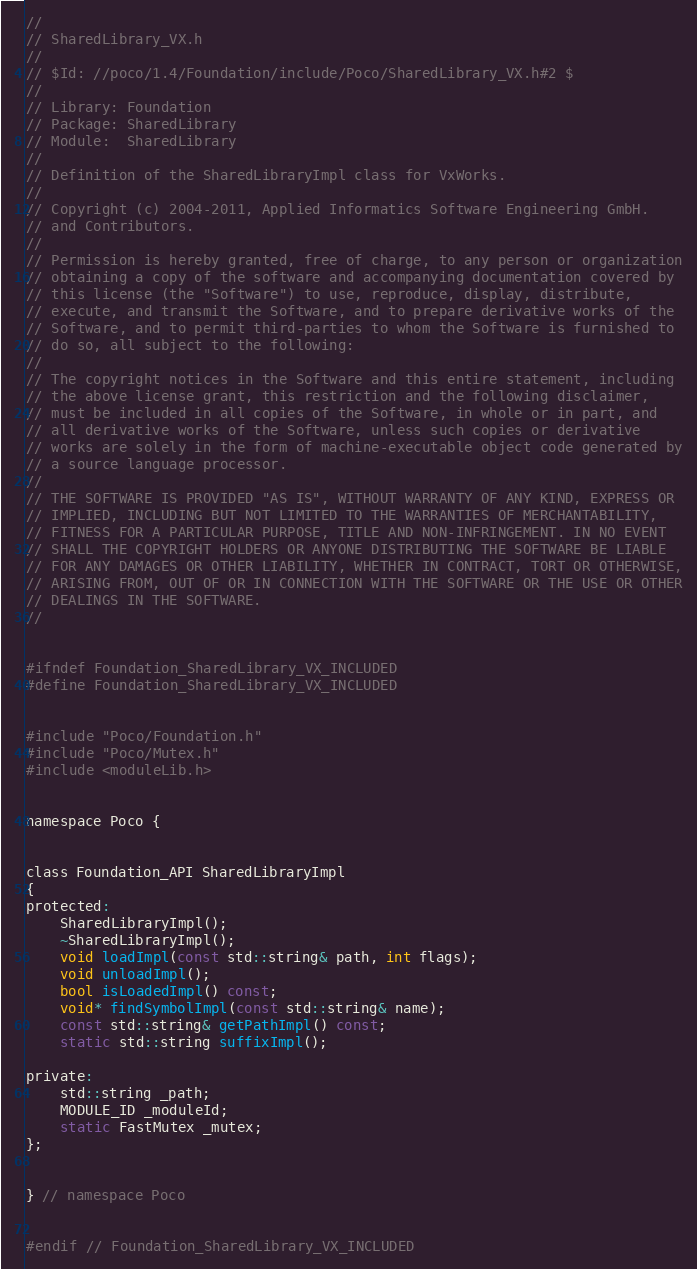Convert code to text. <code><loc_0><loc_0><loc_500><loc_500><_C_>//
// SharedLibrary_VX.h
//
// $Id: //poco/1.4/Foundation/include/Poco/SharedLibrary_VX.h#2 $
//
// Library: Foundation
// Package: SharedLibrary
// Module:  SharedLibrary
//
// Definition of the SharedLibraryImpl class for VxWorks.
//
// Copyright (c) 2004-2011, Applied Informatics Software Engineering GmbH.
// and Contributors.
//
// Permission is hereby granted, free of charge, to any person or organization
// obtaining a copy of the software and accompanying documentation covered by
// this license (the "Software") to use, reproduce, display, distribute,
// execute, and transmit the Software, and to prepare derivative works of the
// Software, and to permit third-parties to whom the Software is furnished to
// do so, all subject to the following:
// 
// The copyright notices in the Software and this entire statement, including
// the above license grant, this restriction and the following disclaimer,
// must be included in all copies of the Software, in whole or in part, and
// all derivative works of the Software, unless such copies or derivative
// works are solely in the form of machine-executable object code generated by
// a source language processor.
// 
// THE SOFTWARE IS PROVIDED "AS IS", WITHOUT WARRANTY OF ANY KIND, EXPRESS OR
// IMPLIED, INCLUDING BUT NOT LIMITED TO THE WARRANTIES OF MERCHANTABILITY,
// FITNESS FOR A PARTICULAR PURPOSE, TITLE AND NON-INFRINGEMENT. IN NO EVENT
// SHALL THE COPYRIGHT HOLDERS OR ANYONE DISTRIBUTING THE SOFTWARE BE LIABLE
// FOR ANY DAMAGES OR OTHER LIABILITY, WHETHER IN CONTRACT, TORT OR OTHERWISE,
// ARISING FROM, OUT OF OR IN CONNECTION WITH THE SOFTWARE OR THE USE OR OTHER
// DEALINGS IN THE SOFTWARE.
//


#ifndef Foundation_SharedLibrary_VX_INCLUDED
#define Foundation_SharedLibrary_VX_INCLUDED


#include "Poco/Foundation.h"
#include "Poco/Mutex.h"
#include <moduleLib.h>


namespace Poco {


class Foundation_API SharedLibraryImpl
{
protected:
	SharedLibraryImpl();
	~SharedLibraryImpl();
	void loadImpl(const std::string& path, int flags);
	void unloadImpl();
	bool isLoadedImpl() const;
	void* findSymbolImpl(const std::string& name);
	const std::string& getPathImpl() const;
	static std::string suffixImpl();

private:
	std::string _path;
	MODULE_ID _moduleId;
	static FastMutex _mutex;
};


} // namespace Poco


#endif // Foundation_SharedLibrary_VX_INCLUDED
</code> 